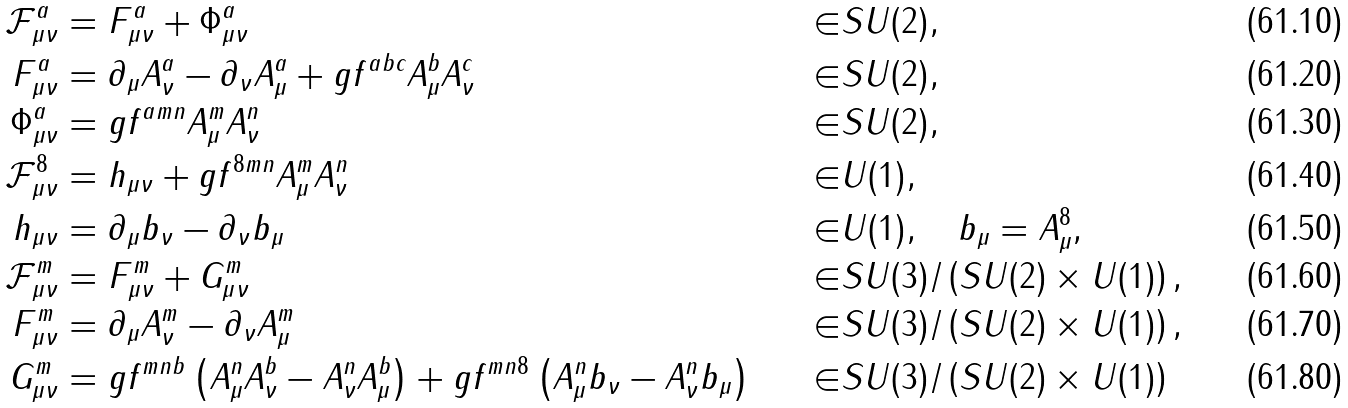Convert formula to latex. <formula><loc_0><loc_0><loc_500><loc_500>\mathcal { F } ^ { a } _ { \mu \nu } & = F ^ { a } _ { \mu \nu } + \Phi ^ { a } _ { \mu \nu } & \in & S U ( 2 ) , \\ F ^ { a } _ { \mu \nu } & = \partial _ { \mu } A ^ { a } _ { \nu } - \partial _ { \nu } A ^ { a } _ { \mu } + g f ^ { a b c } A ^ { b } _ { \mu } A ^ { c } _ { \nu } & \in & S U ( 2 ) , \\ \Phi ^ { a } _ { \mu \nu } & = g f ^ { a m n } A ^ { m } _ { \mu } A ^ { n } _ { \nu } & \in & S U ( 2 ) , \\ \mathcal { F } ^ { 8 } _ { \mu \nu } & = h _ { \mu \nu } + g f ^ { 8 m n } A ^ { m } _ { \mu } A ^ { n } _ { \nu } & \in & U ( 1 ) , \\ h _ { \mu \nu } & = \partial _ { \mu } b _ { \nu } - \partial _ { \nu } b _ { \mu } & \in & U ( 1 ) , \quad b _ { \mu } = A ^ { 8 } _ { \mu } , \\ \mathcal { F } ^ { m } _ { \mu \nu } & = F ^ { m } _ { \mu \nu } + G ^ { m } _ { \mu \nu } & \in & S U ( 3 ) / \left ( S U ( 2 ) \times U ( 1 ) \right ) , \\ F ^ { m } _ { \mu \nu } & = \partial _ { \mu } A ^ { m } _ { \nu } - \partial _ { \nu } A ^ { m } _ { \mu } & \in & S U ( 3 ) / \left ( S U ( 2 ) \times U ( 1 ) \right ) , \\ G ^ { m } _ { \mu \nu } & = g f ^ { m n b } \left ( A ^ { n } _ { \mu } A ^ { b } _ { \nu } - A ^ { n } _ { \nu } A ^ { b } _ { \mu } \right ) + g f ^ { m n 8 } \left ( A ^ { n } _ { \mu } b _ { \nu } - A ^ { n } _ { \nu } b _ { \mu } \right ) & \in & S U ( 3 ) / \left ( S U ( 2 ) \times U ( 1 ) \right )</formula> 